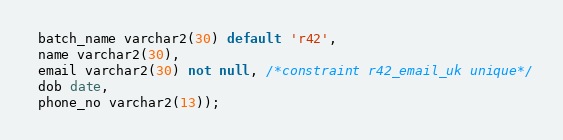Convert code to text. <code><loc_0><loc_0><loc_500><loc_500><_SQL_> batch_name varchar2(30) default 'r42',
 name varchar2(30),
 email varchar2(30) not null, /*constraint r42_email_uk unique*/
 dob date,
 phone_no varchar2(13));</code> 